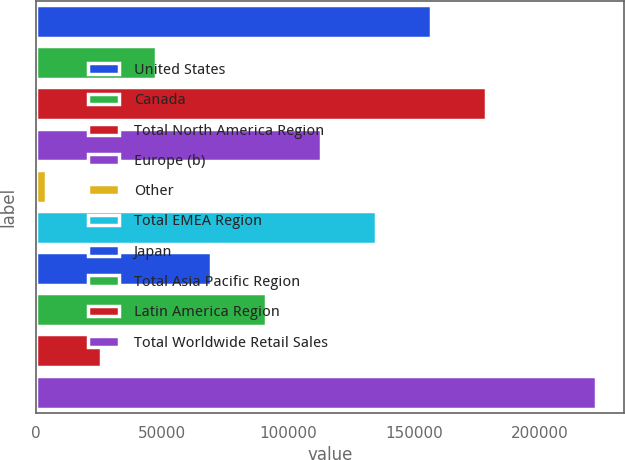<chart> <loc_0><loc_0><loc_500><loc_500><bar_chart><fcel>United States<fcel>Canada<fcel>Total North America Region<fcel>Europe (b)<fcel>Other<fcel>Total EMEA Region<fcel>Japan<fcel>Total Asia Pacific Region<fcel>Latin America Region<fcel>Total Worldwide Retail Sales<nl><fcel>156620<fcel>47470<fcel>178450<fcel>112960<fcel>3810<fcel>134790<fcel>69300<fcel>91130<fcel>25640<fcel>222110<nl></chart> 